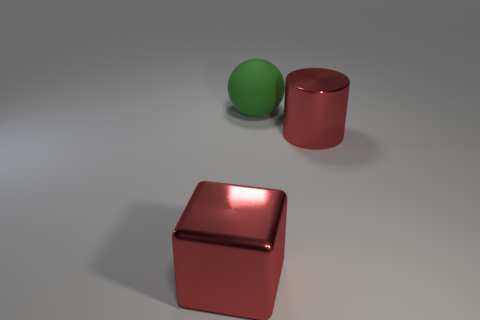Add 1 tiny yellow cylinders. How many objects exist? 4 Subtract all cubes. How many objects are left? 2 Add 1 large red cubes. How many large red cubes exist? 2 Subtract 0 brown cubes. How many objects are left? 3 Subtract all tiny gray balls. Subtract all big red things. How many objects are left? 1 Add 2 metal cylinders. How many metal cylinders are left? 3 